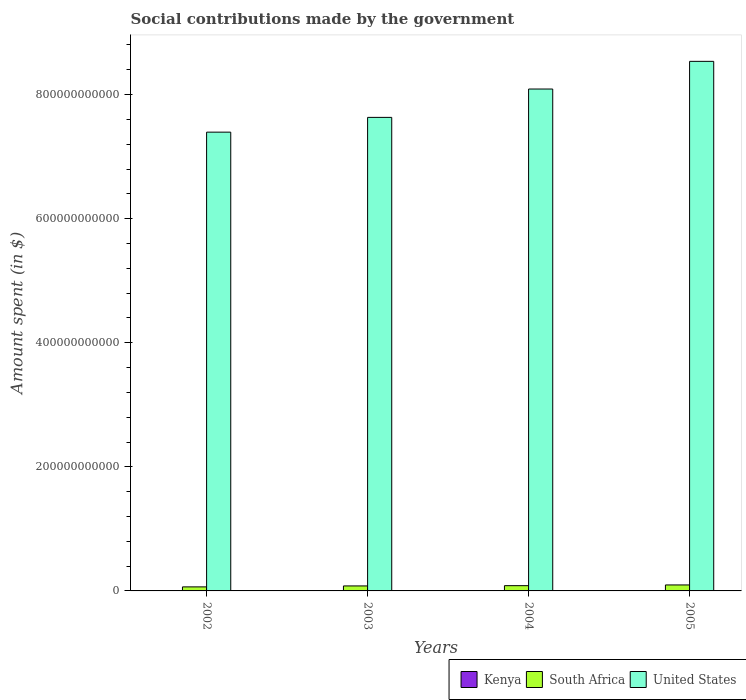Are the number of bars per tick equal to the number of legend labels?
Make the answer very short. Yes. What is the label of the 3rd group of bars from the left?
Provide a short and direct response. 2004. In how many cases, is the number of bars for a given year not equal to the number of legend labels?
Your answer should be compact. 0. What is the amount spent on social contributions in South Africa in 2005?
Provide a succinct answer. 9.63e+09. Across all years, what is the maximum amount spent on social contributions in South Africa?
Your answer should be compact. 9.63e+09. Across all years, what is the minimum amount spent on social contributions in South Africa?
Your answer should be compact. 6.51e+09. In which year was the amount spent on social contributions in South Africa minimum?
Your answer should be very brief. 2002. What is the total amount spent on social contributions in Kenya in the graph?
Your answer should be compact. 1.68e+09. What is the difference between the amount spent on social contributions in Kenya in 2002 and that in 2003?
Make the answer very short. -3.62e+07. What is the difference between the amount spent on social contributions in South Africa in 2005 and the amount spent on social contributions in Kenya in 2003?
Give a very brief answer. 9.17e+09. What is the average amount spent on social contributions in South Africa per year?
Keep it short and to the point. 8.16e+09. In the year 2003, what is the difference between the amount spent on social contributions in Kenya and amount spent on social contributions in South Africa?
Offer a terse response. -7.58e+09. What is the ratio of the amount spent on social contributions in South Africa in 2002 to that in 2003?
Provide a short and direct response. 0.81. What is the difference between the highest and the second highest amount spent on social contributions in Kenya?
Ensure brevity in your answer.  9.81e+07. What is the difference between the highest and the lowest amount spent on social contributions in United States?
Offer a terse response. 1.14e+11. Is the sum of the amount spent on social contributions in Kenya in 2002 and 2005 greater than the maximum amount spent on social contributions in United States across all years?
Make the answer very short. No. What does the 2nd bar from the right in 2002 represents?
Provide a succinct answer. South Africa. Is it the case that in every year, the sum of the amount spent on social contributions in South Africa and amount spent on social contributions in Kenya is greater than the amount spent on social contributions in United States?
Provide a succinct answer. No. What is the difference between two consecutive major ticks on the Y-axis?
Keep it short and to the point. 2.00e+11. Does the graph contain grids?
Your response must be concise. No. What is the title of the graph?
Provide a succinct answer. Social contributions made by the government. Does "Somalia" appear as one of the legend labels in the graph?
Offer a very short reply. No. What is the label or title of the Y-axis?
Your answer should be very brief. Amount spent (in $). What is the Amount spent (in $) in Kenya in 2002?
Offer a terse response. 4.24e+08. What is the Amount spent (in $) in South Africa in 2002?
Make the answer very short. 6.51e+09. What is the Amount spent (in $) of United States in 2002?
Your answer should be very brief. 7.39e+11. What is the Amount spent (in $) of Kenya in 2003?
Provide a short and direct response. 4.60e+08. What is the Amount spent (in $) of South Africa in 2003?
Give a very brief answer. 8.04e+09. What is the Amount spent (in $) of United States in 2003?
Your answer should be compact. 7.63e+11. What is the Amount spent (in $) of Kenya in 2004?
Provide a short and direct response. 2.39e+08. What is the Amount spent (in $) of South Africa in 2004?
Offer a very short reply. 8.47e+09. What is the Amount spent (in $) in United States in 2004?
Keep it short and to the point. 8.09e+11. What is the Amount spent (in $) in Kenya in 2005?
Ensure brevity in your answer.  5.58e+08. What is the Amount spent (in $) in South Africa in 2005?
Ensure brevity in your answer.  9.63e+09. What is the Amount spent (in $) of United States in 2005?
Ensure brevity in your answer.  8.54e+11. Across all years, what is the maximum Amount spent (in $) of Kenya?
Your answer should be compact. 5.58e+08. Across all years, what is the maximum Amount spent (in $) in South Africa?
Provide a short and direct response. 9.63e+09. Across all years, what is the maximum Amount spent (in $) of United States?
Give a very brief answer. 8.54e+11. Across all years, what is the minimum Amount spent (in $) in Kenya?
Keep it short and to the point. 2.39e+08. Across all years, what is the minimum Amount spent (in $) in South Africa?
Ensure brevity in your answer.  6.51e+09. Across all years, what is the minimum Amount spent (in $) in United States?
Offer a very short reply. 7.39e+11. What is the total Amount spent (in $) in Kenya in the graph?
Give a very brief answer. 1.68e+09. What is the total Amount spent (in $) of South Africa in the graph?
Give a very brief answer. 3.27e+1. What is the total Amount spent (in $) in United States in the graph?
Give a very brief answer. 3.16e+12. What is the difference between the Amount spent (in $) in Kenya in 2002 and that in 2003?
Ensure brevity in your answer.  -3.62e+07. What is the difference between the Amount spent (in $) of South Africa in 2002 and that in 2003?
Your answer should be very brief. -1.54e+09. What is the difference between the Amount spent (in $) in United States in 2002 and that in 2003?
Make the answer very short. -2.38e+1. What is the difference between the Amount spent (in $) in Kenya in 2002 and that in 2004?
Give a very brief answer. 1.85e+08. What is the difference between the Amount spent (in $) in South Africa in 2002 and that in 2004?
Make the answer very short. -1.97e+09. What is the difference between the Amount spent (in $) of United States in 2002 and that in 2004?
Offer a terse response. -6.95e+1. What is the difference between the Amount spent (in $) in Kenya in 2002 and that in 2005?
Give a very brief answer. -1.34e+08. What is the difference between the Amount spent (in $) of South Africa in 2002 and that in 2005?
Your answer should be very brief. -3.13e+09. What is the difference between the Amount spent (in $) in United States in 2002 and that in 2005?
Provide a short and direct response. -1.14e+11. What is the difference between the Amount spent (in $) of Kenya in 2003 and that in 2004?
Provide a short and direct response. 2.21e+08. What is the difference between the Amount spent (in $) of South Africa in 2003 and that in 2004?
Your answer should be compact. -4.30e+08. What is the difference between the Amount spent (in $) in United States in 2003 and that in 2004?
Provide a short and direct response. -4.57e+1. What is the difference between the Amount spent (in $) in Kenya in 2003 and that in 2005?
Provide a succinct answer. -9.81e+07. What is the difference between the Amount spent (in $) in South Africa in 2003 and that in 2005?
Your answer should be very brief. -1.59e+09. What is the difference between the Amount spent (in $) in United States in 2003 and that in 2005?
Your response must be concise. -9.03e+1. What is the difference between the Amount spent (in $) in Kenya in 2004 and that in 2005?
Keep it short and to the point. -3.19e+08. What is the difference between the Amount spent (in $) in South Africa in 2004 and that in 2005?
Your answer should be very brief. -1.16e+09. What is the difference between the Amount spent (in $) of United States in 2004 and that in 2005?
Make the answer very short. -4.46e+1. What is the difference between the Amount spent (in $) in Kenya in 2002 and the Amount spent (in $) in South Africa in 2003?
Give a very brief answer. -7.62e+09. What is the difference between the Amount spent (in $) in Kenya in 2002 and the Amount spent (in $) in United States in 2003?
Offer a terse response. -7.63e+11. What is the difference between the Amount spent (in $) in South Africa in 2002 and the Amount spent (in $) in United States in 2003?
Give a very brief answer. -7.57e+11. What is the difference between the Amount spent (in $) of Kenya in 2002 and the Amount spent (in $) of South Africa in 2004?
Provide a succinct answer. -8.05e+09. What is the difference between the Amount spent (in $) in Kenya in 2002 and the Amount spent (in $) in United States in 2004?
Your response must be concise. -8.08e+11. What is the difference between the Amount spent (in $) in South Africa in 2002 and the Amount spent (in $) in United States in 2004?
Offer a very short reply. -8.02e+11. What is the difference between the Amount spent (in $) in Kenya in 2002 and the Amount spent (in $) in South Africa in 2005?
Give a very brief answer. -9.21e+09. What is the difference between the Amount spent (in $) of Kenya in 2002 and the Amount spent (in $) of United States in 2005?
Ensure brevity in your answer.  -8.53e+11. What is the difference between the Amount spent (in $) in South Africa in 2002 and the Amount spent (in $) in United States in 2005?
Make the answer very short. -8.47e+11. What is the difference between the Amount spent (in $) in Kenya in 2003 and the Amount spent (in $) in South Africa in 2004?
Your answer should be very brief. -8.01e+09. What is the difference between the Amount spent (in $) of Kenya in 2003 and the Amount spent (in $) of United States in 2004?
Give a very brief answer. -8.08e+11. What is the difference between the Amount spent (in $) of South Africa in 2003 and the Amount spent (in $) of United States in 2004?
Ensure brevity in your answer.  -8.01e+11. What is the difference between the Amount spent (in $) of Kenya in 2003 and the Amount spent (in $) of South Africa in 2005?
Make the answer very short. -9.17e+09. What is the difference between the Amount spent (in $) in Kenya in 2003 and the Amount spent (in $) in United States in 2005?
Keep it short and to the point. -8.53e+11. What is the difference between the Amount spent (in $) in South Africa in 2003 and the Amount spent (in $) in United States in 2005?
Your response must be concise. -8.45e+11. What is the difference between the Amount spent (in $) of Kenya in 2004 and the Amount spent (in $) of South Africa in 2005?
Keep it short and to the point. -9.39e+09. What is the difference between the Amount spent (in $) in Kenya in 2004 and the Amount spent (in $) in United States in 2005?
Make the answer very short. -8.53e+11. What is the difference between the Amount spent (in $) of South Africa in 2004 and the Amount spent (in $) of United States in 2005?
Your answer should be very brief. -8.45e+11. What is the average Amount spent (in $) in Kenya per year?
Make the answer very short. 4.20e+08. What is the average Amount spent (in $) in South Africa per year?
Make the answer very short. 8.16e+09. What is the average Amount spent (in $) of United States per year?
Your response must be concise. 7.91e+11. In the year 2002, what is the difference between the Amount spent (in $) of Kenya and Amount spent (in $) of South Africa?
Give a very brief answer. -6.08e+09. In the year 2002, what is the difference between the Amount spent (in $) of Kenya and Amount spent (in $) of United States?
Give a very brief answer. -7.39e+11. In the year 2002, what is the difference between the Amount spent (in $) of South Africa and Amount spent (in $) of United States?
Ensure brevity in your answer.  -7.33e+11. In the year 2003, what is the difference between the Amount spent (in $) of Kenya and Amount spent (in $) of South Africa?
Make the answer very short. -7.58e+09. In the year 2003, what is the difference between the Amount spent (in $) in Kenya and Amount spent (in $) in United States?
Make the answer very short. -7.63e+11. In the year 2003, what is the difference between the Amount spent (in $) of South Africa and Amount spent (in $) of United States?
Offer a very short reply. -7.55e+11. In the year 2004, what is the difference between the Amount spent (in $) of Kenya and Amount spent (in $) of South Africa?
Provide a succinct answer. -8.23e+09. In the year 2004, what is the difference between the Amount spent (in $) in Kenya and Amount spent (in $) in United States?
Keep it short and to the point. -8.09e+11. In the year 2004, what is the difference between the Amount spent (in $) in South Africa and Amount spent (in $) in United States?
Ensure brevity in your answer.  -8.00e+11. In the year 2005, what is the difference between the Amount spent (in $) of Kenya and Amount spent (in $) of South Africa?
Keep it short and to the point. -9.08e+09. In the year 2005, what is the difference between the Amount spent (in $) in Kenya and Amount spent (in $) in United States?
Offer a terse response. -8.53e+11. In the year 2005, what is the difference between the Amount spent (in $) of South Africa and Amount spent (in $) of United States?
Your response must be concise. -8.44e+11. What is the ratio of the Amount spent (in $) of Kenya in 2002 to that in 2003?
Offer a terse response. 0.92. What is the ratio of the Amount spent (in $) in South Africa in 2002 to that in 2003?
Keep it short and to the point. 0.81. What is the ratio of the Amount spent (in $) of United States in 2002 to that in 2003?
Your answer should be compact. 0.97. What is the ratio of the Amount spent (in $) of Kenya in 2002 to that in 2004?
Provide a succinct answer. 1.77. What is the ratio of the Amount spent (in $) in South Africa in 2002 to that in 2004?
Your response must be concise. 0.77. What is the ratio of the Amount spent (in $) in United States in 2002 to that in 2004?
Make the answer very short. 0.91. What is the ratio of the Amount spent (in $) in Kenya in 2002 to that in 2005?
Your answer should be very brief. 0.76. What is the ratio of the Amount spent (in $) in South Africa in 2002 to that in 2005?
Offer a very short reply. 0.68. What is the ratio of the Amount spent (in $) of United States in 2002 to that in 2005?
Provide a short and direct response. 0.87. What is the ratio of the Amount spent (in $) of Kenya in 2003 to that in 2004?
Provide a short and direct response. 1.92. What is the ratio of the Amount spent (in $) of South Africa in 2003 to that in 2004?
Your answer should be very brief. 0.95. What is the ratio of the Amount spent (in $) of United States in 2003 to that in 2004?
Give a very brief answer. 0.94. What is the ratio of the Amount spent (in $) of Kenya in 2003 to that in 2005?
Your response must be concise. 0.82. What is the ratio of the Amount spent (in $) of South Africa in 2003 to that in 2005?
Make the answer very short. 0.83. What is the ratio of the Amount spent (in $) in United States in 2003 to that in 2005?
Provide a succinct answer. 0.89. What is the ratio of the Amount spent (in $) of Kenya in 2004 to that in 2005?
Your answer should be very brief. 0.43. What is the ratio of the Amount spent (in $) in South Africa in 2004 to that in 2005?
Provide a short and direct response. 0.88. What is the ratio of the Amount spent (in $) of United States in 2004 to that in 2005?
Keep it short and to the point. 0.95. What is the difference between the highest and the second highest Amount spent (in $) in Kenya?
Ensure brevity in your answer.  9.81e+07. What is the difference between the highest and the second highest Amount spent (in $) in South Africa?
Give a very brief answer. 1.16e+09. What is the difference between the highest and the second highest Amount spent (in $) in United States?
Give a very brief answer. 4.46e+1. What is the difference between the highest and the lowest Amount spent (in $) of Kenya?
Your answer should be compact. 3.19e+08. What is the difference between the highest and the lowest Amount spent (in $) in South Africa?
Provide a succinct answer. 3.13e+09. What is the difference between the highest and the lowest Amount spent (in $) of United States?
Offer a terse response. 1.14e+11. 